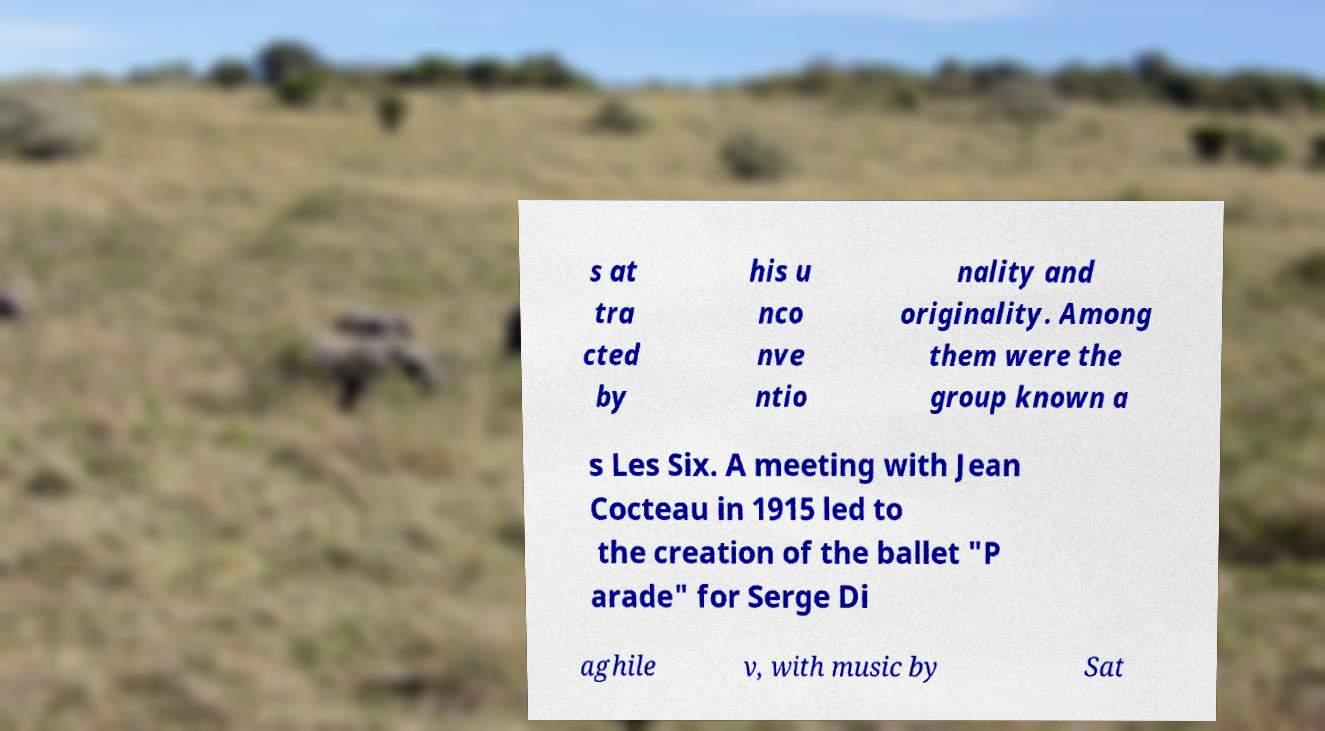There's text embedded in this image that I need extracted. Can you transcribe it verbatim? s at tra cted by his u nco nve ntio nality and originality. Among them were the group known a s Les Six. A meeting with Jean Cocteau in 1915 led to the creation of the ballet "P arade" for Serge Di aghile v, with music by Sat 